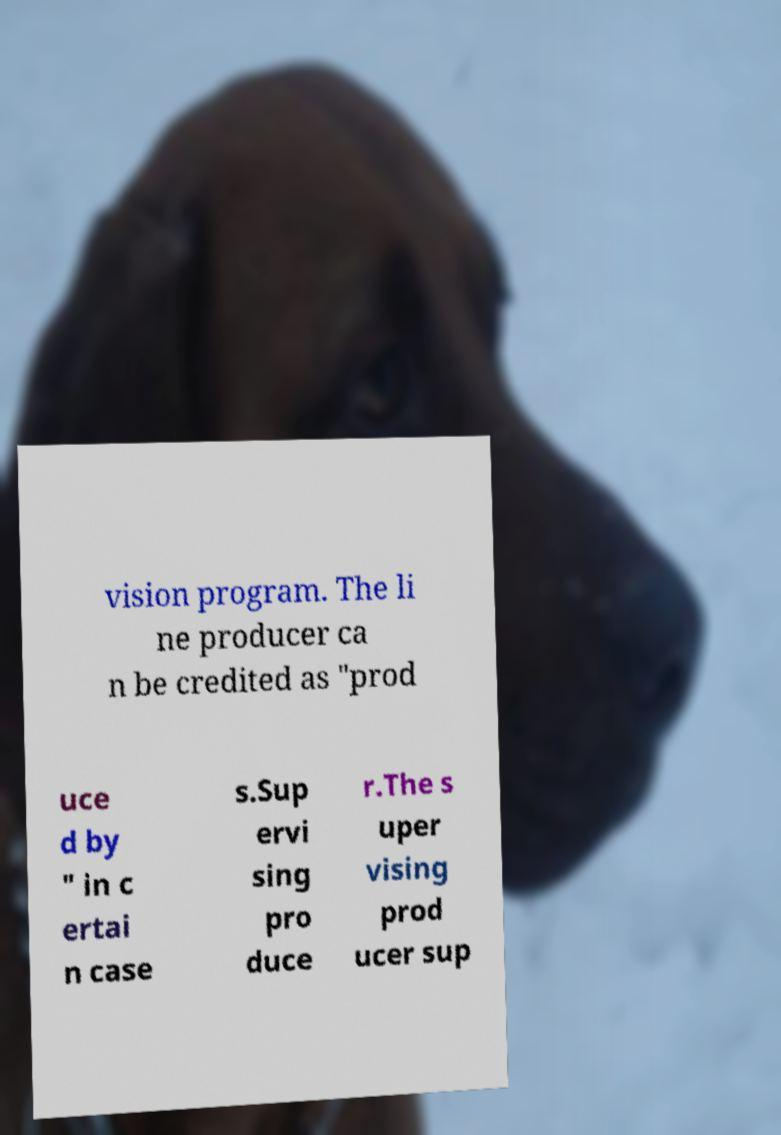Could you assist in decoding the text presented in this image and type it out clearly? vision program. The li ne producer ca n be credited as "prod uce d by " in c ertai n case s.Sup ervi sing pro duce r.The s uper vising prod ucer sup 